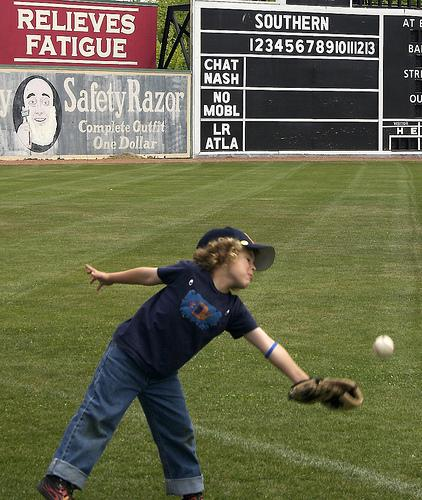What is the color of the scoreboard behind the child, and where is it located in the image? The scoreboard is black and white, located at the top-center of the image. What color are the lines on the grass, and where do they appear in the image? The lines on the grass are white, appearing at the bottom of the image. Describe any unique features of the boy's pants in the image. The boy's pants are cuffed, and there are wrinkles on the knee of his pants. In the image, describe the child's hair and whether they're wearing any head accessories. The child has curly hair under a blue cap on their head. What type of glove is the child wearing, and what color is it? The child is wearing a brown leather catcher's mitt. What is the color of the band on the child's arm and what is its position? The band on the child's right arm is blue in color. Provide a brief overview of the scene, mentioning the child's clothing and the setting. A young boy wearing blue pants, a blue short-sleeved t-shirt, and a blue cap is playing baseball in a large green grassy field with a scoreboard in the background. Describe the unique feature of the boy's shoes in this image. The boy's shoes are black with red flames design. Identify the main activity happening in the image and what color the ball involved is. The main activity is a boy playing baseball, and the ball is white in color. Select the appropriate caption for the image: b) a boy playing baseball Based on the image, describe the clothing and accessories worn by the young boy. blue pants with cuffed pantlegs, blue short-sleeved t-shirt, navy blue cap, black shoes with red flames, blue band on arm, and a brown glove What is the child wearing? blue pants, blue short-sleeved t-shirt, brown glove, hat, and black shoes with red flames Locate the baseball in the given image. in the air Examine the image and provide a description of the environment. a grassy field with a scoreboard, white lines painted on the grass, and a chalk line Choose the correct statement: b) the boy has a brown glove What color are the lines painted on the grass? white Analyze the interaction between the boy and the baseball in the image. the baseball is airborne, and the boy is trying to catch it with his baseball mitt Which activity is the young boy engaged in? playing baseball What is the overall theme of the image? a boy playing baseball in a grassy field What can be observed on the boy's pants? cuffed pantleg, wrinkles on knee Describe the child's hat. navy blue cap Can you identify any unique features on the boy's shoes? black shoes with red flames What type of band is on the boy's arm and what color is it? a blue band Mention the different colors in the image. blue, brown, white, black, green, red Identify any changes made to the boy's pants. the pantleg is rolled up Observe the baseball mitt on the boy's hand and describe its appearance. a brown leather catcher's mitt From the image, mention the position of the baseball. flying in the air What does the scoreboard behind the child look like? it is a black and white scoreboard, large in size 